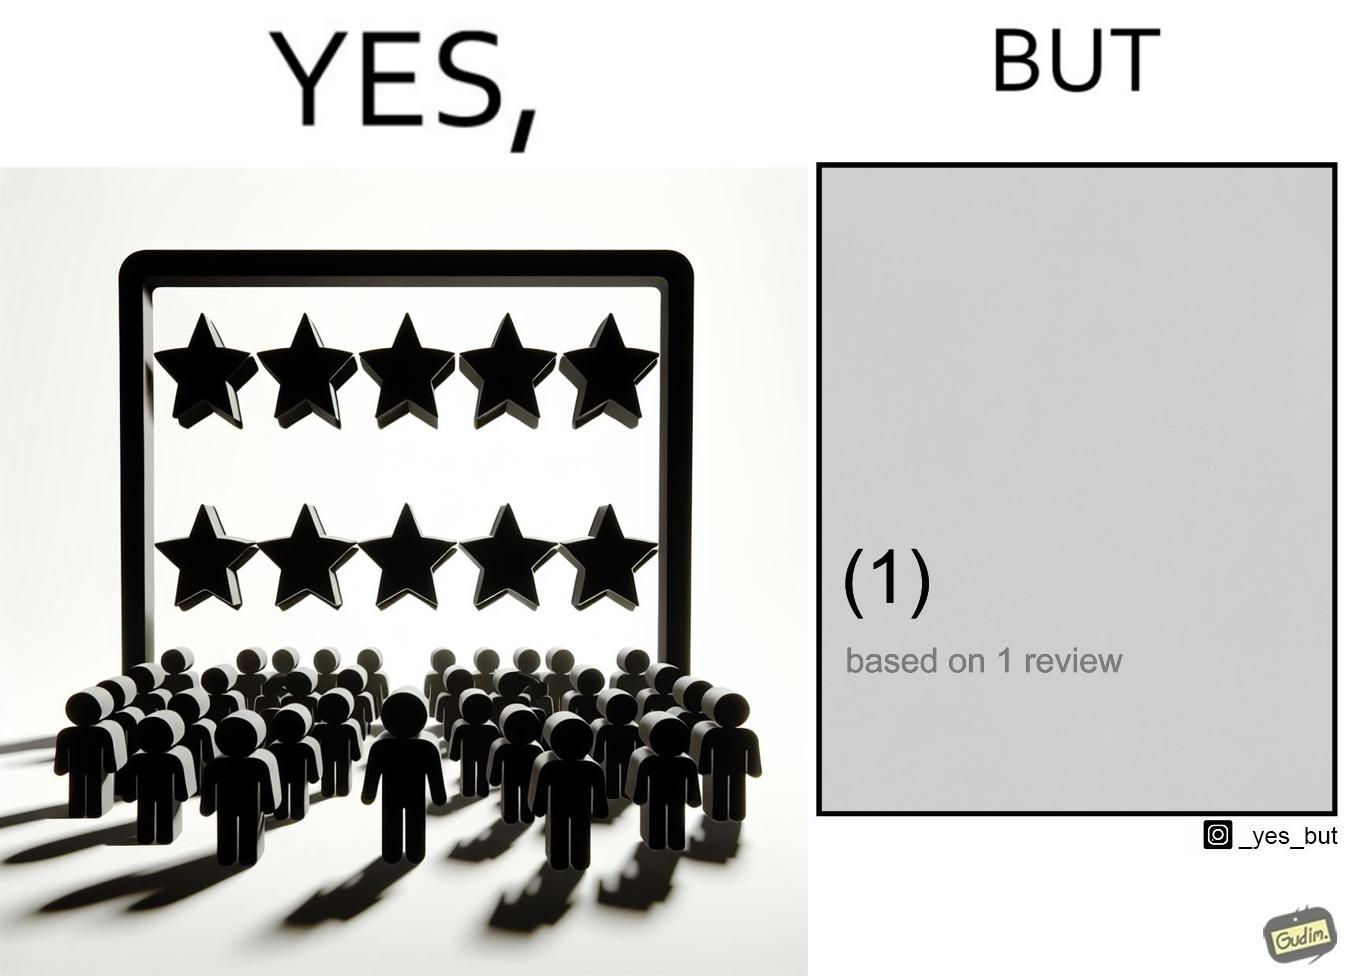Is this a satirical image? Yes, this image is satirical. 